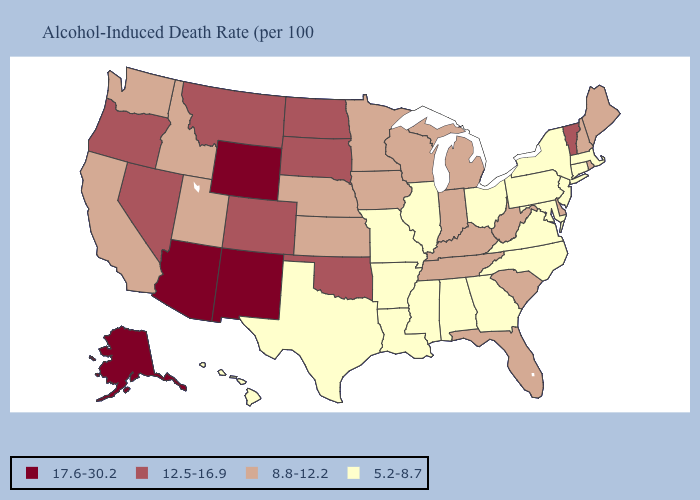Among the states that border Massachusetts , does Rhode Island have the lowest value?
Keep it brief. No. What is the value of Arkansas?
Write a very short answer. 5.2-8.7. Which states have the highest value in the USA?
Be succinct. Alaska, Arizona, New Mexico, Wyoming. Among the states that border North Carolina , does Virginia have the highest value?
Quick response, please. No. Which states have the highest value in the USA?
Be succinct. Alaska, Arizona, New Mexico, Wyoming. Does Washington have the same value as Maine?
Concise answer only. Yes. What is the highest value in the USA?
Keep it brief. 17.6-30.2. Does Kentucky have the highest value in the South?
Give a very brief answer. No. How many symbols are there in the legend?
Give a very brief answer. 4. Among the states that border Colorado , does Utah have the lowest value?
Answer briefly. Yes. What is the value of Oregon?
Keep it brief. 12.5-16.9. What is the value of New York?
Be succinct. 5.2-8.7. Name the states that have a value in the range 8.8-12.2?
Concise answer only. California, Delaware, Florida, Idaho, Indiana, Iowa, Kansas, Kentucky, Maine, Michigan, Minnesota, Nebraska, New Hampshire, Rhode Island, South Carolina, Tennessee, Utah, Washington, West Virginia, Wisconsin. What is the value of South Dakota?
Answer briefly. 12.5-16.9. 